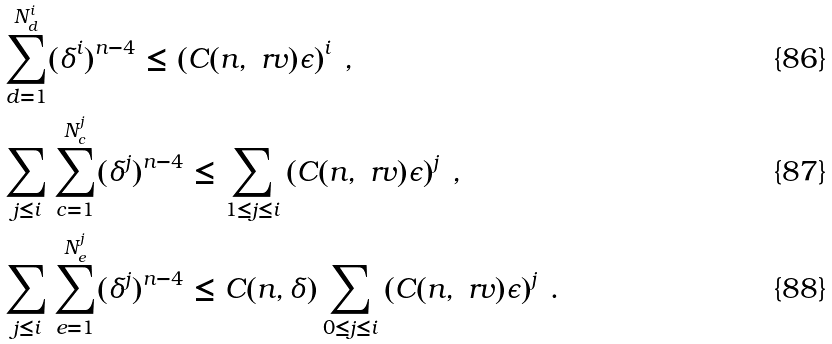Convert formula to latex. <formula><loc_0><loc_0><loc_500><loc_500>& \sum _ { d = 1 } ^ { N ^ { i } _ { d } } ( \delta ^ { i } ) ^ { n - 4 } \leq \left ( C ( n , \ r v ) \epsilon \right ) ^ { i } \, , \\ & \sum _ { j \leq i } \sum _ { c = 1 } ^ { N ^ { j } _ { c } } ( \delta ^ { j } ) ^ { n - 4 } \leq \sum _ { 1 \leq j \leq i } \left ( C ( n , \ r v ) \epsilon \right ) ^ { j } \, , \\ & \sum _ { j \leq i } \sum _ { e = 1 } ^ { N ^ { j } _ { e } } ( \delta ^ { j } ) ^ { n - 4 } \leq C ( n , \delta ) \sum _ { 0 \leq j \leq i } \left ( C ( n , \ r v ) \epsilon \right ) ^ { j } \, .</formula> 